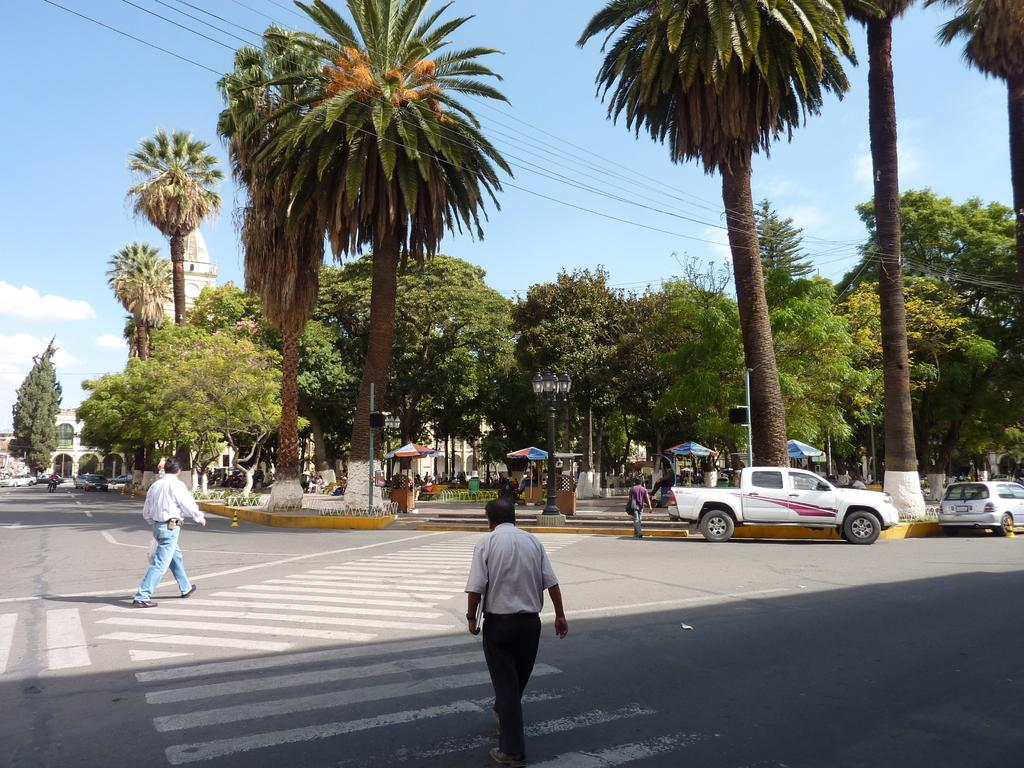Who or what can be seen in the image? There are people in the image. What else is happening in the image? There are vehicles moving on the road in the image. What can be seen in the background of the image? There are trees and the sky visible in the background of the image. Are there any people near the trees in the background? Yes, there are people beneath the trees in the background of the image. What type of instrument is being played by the people beneath the trees in the image? There is no instrument being played by the people beneath the trees in the image. Is there a fire visible in the image? No, there is no fire visible in the image. 